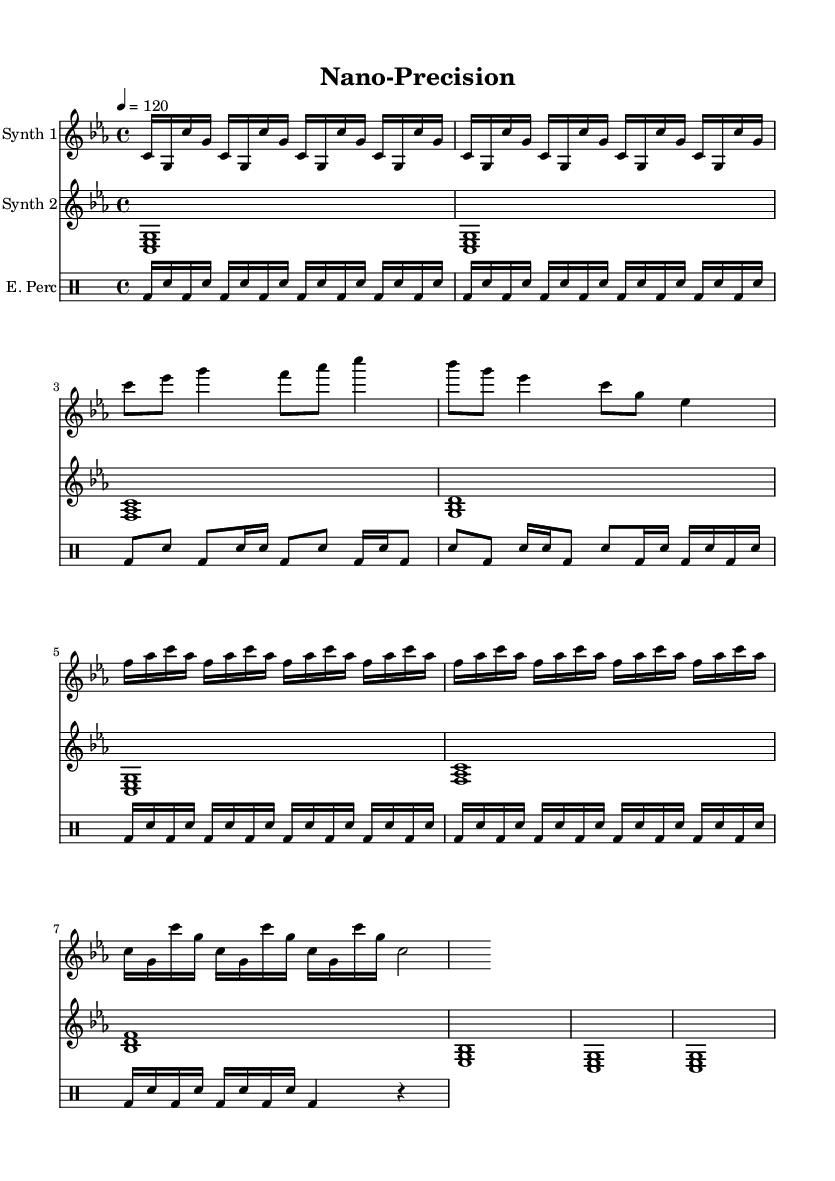What is the key signature of this music? The key signature is C minor, which has three flats: B flat, E flat, and A flat. This can be identified at the beginning of the sheet music in the key signature section before the time signature.
Answer: C minor What is the time signature of this piece? The time signature is 4/4, meaning there are four beats in each measure and the quarter note gets one beat. This can be found in the time signature section at the beginning of the score.
Answer: 4/4 What is the tempo marking for this composition? The tempo marking is indicated as "4 = 120", which means that a quarter note should be played at 120 beats per minute. This is found in the tempo section at the beginning of the score.
Answer: 120 How many sections are in the composition? The composition consists of four distinct sections: Intro, Section A, Section B, and Outro. This can be deduced by analyzing the structure as indicated by the music notation.
Answer: Four What type of synthesizer is used in the first staff? The first staff is labeled as "Synth 1," which indicates that it represents a synthesizer part. This can be found in the instrument name labeling at the start of that staff.
Answer: Synth 1 Which two notes are repeated most frequently in the Intro of Synth 1? The notes "c" and "g" appear in a repeated pattern throughout the Intro section of Synth 1, particularly in the first few measures. Analyzing the notation in this section shows these notes being emphasized.
Answer: C and G What rhythmic pattern does the percussion follow in the Outro? The percussion part in the Outro follows a pattern of bass drum and snare hits, reflecting a repeating cycle that is laid out clearly in the notation. By looking closely at the measures in the Outro, this repetitive rhythmic structure is evident.
Answer: Bass drum and snare 